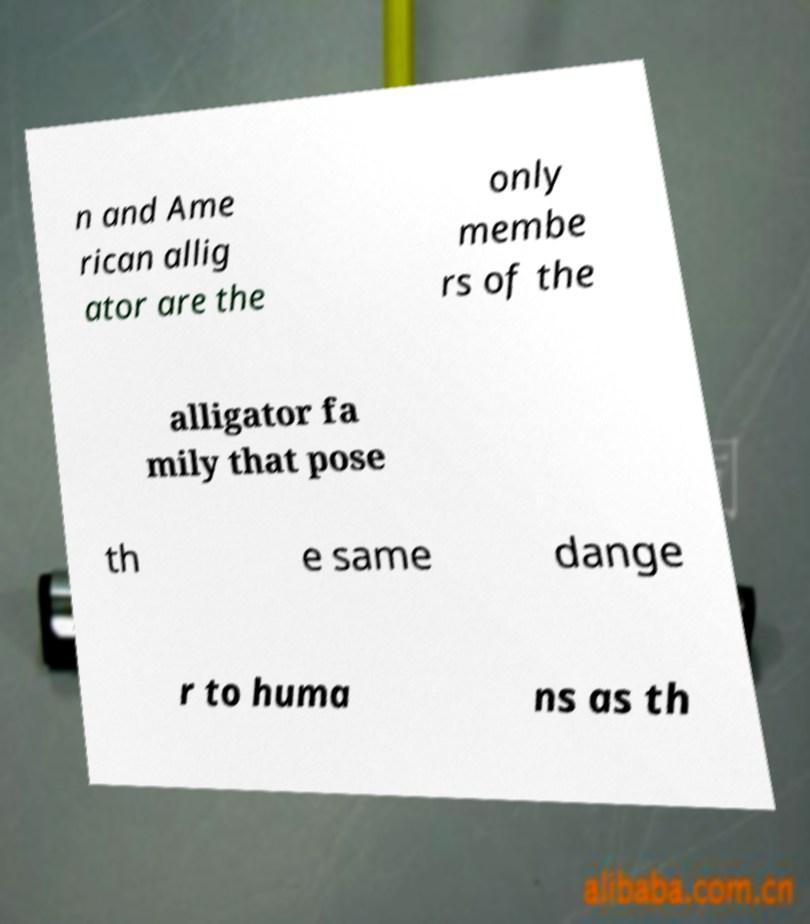Could you assist in decoding the text presented in this image and type it out clearly? n and Ame rican allig ator are the only membe rs of the alligator fa mily that pose th e same dange r to huma ns as th 